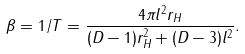<formula> <loc_0><loc_0><loc_500><loc_500>\beta = 1 / T = \frac { 4 \pi l ^ { 2 } r _ { H } } { ( D - 1 ) r _ { H } ^ { 2 } + ( D - 3 ) l ^ { 2 } } .</formula> 